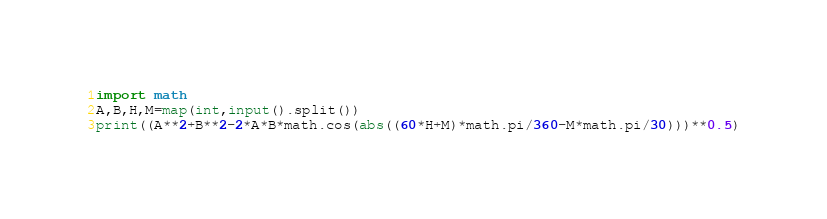Convert code to text. <code><loc_0><loc_0><loc_500><loc_500><_Python_>import math
A,B,H,M=map(int,input().split())
print((A**2+B**2-2*A*B*math.cos(abs((60*H+M)*math.pi/360-M*math.pi/30)))**0.5)</code> 